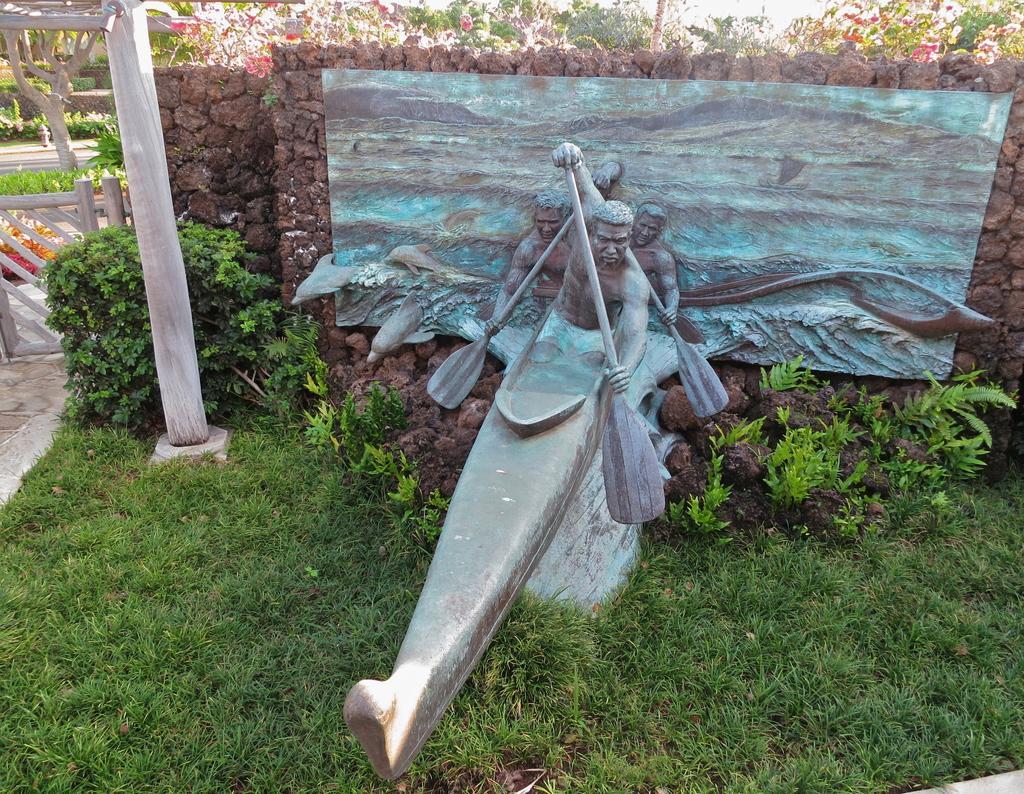Describe this image in one or two sentences. In the foreground I can see a sculpture of four persons on the boat, grass, plants and a pillar. In the background I can see a stone fence and flowering plants. This image is taken may be in a park during a day. 